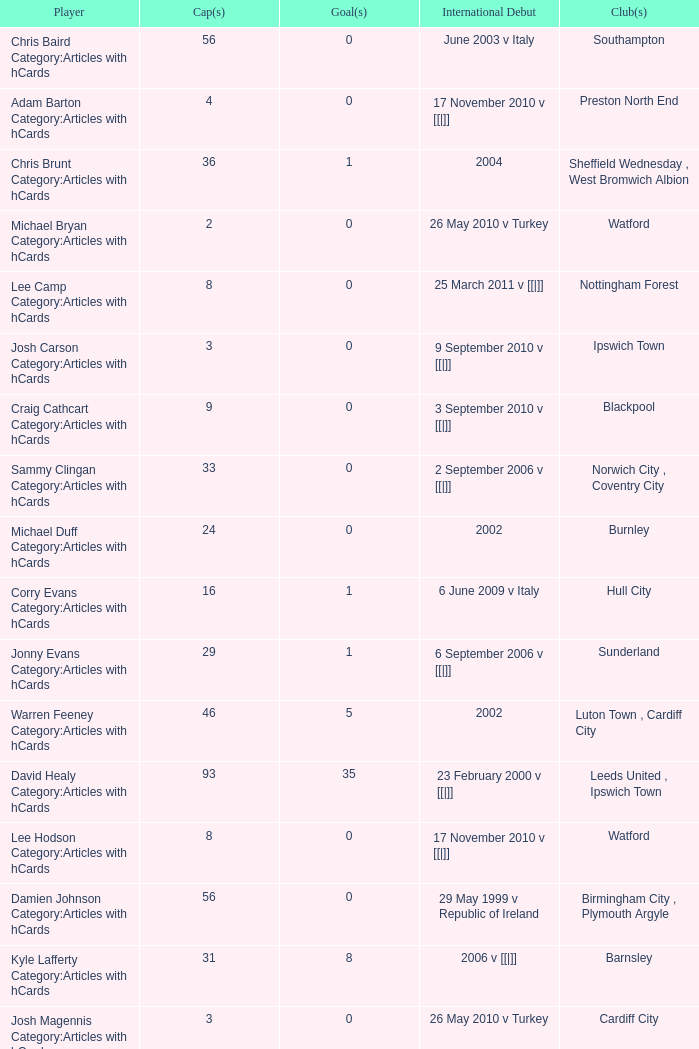How many cap numbers are there for norwich city, coventry city? 1.0. 